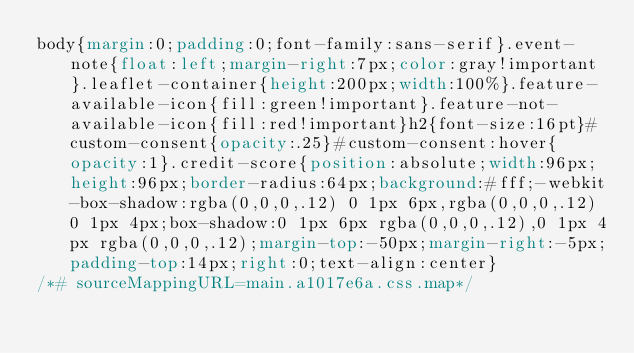Convert code to text. <code><loc_0><loc_0><loc_500><loc_500><_CSS_>body{margin:0;padding:0;font-family:sans-serif}.event-note{float:left;margin-right:7px;color:gray!important}.leaflet-container{height:200px;width:100%}.feature-available-icon{fill:green!important}.feature-not-available-icon{fill:red!important}h2{font-size:16pt}#custom-consent{opacity:.25}#custom-consent:hover{opacity:1}.credit-score{position:absolute;width:96px;height:96px;border-radius:64px;background:#fff;-webkit-box-shadow:rgba(0,0,0,.12) 0 1px 6px,rgba(0,0,0,.12) 0 1px 4px;box-shadow:0 1px 6px rgba(0,0,0,.12),0 1px 4px rgba(0,0,0,.12);margin-top:-50px;margin-right:-5px;padding-top:14px;right:0;text-align:center}
/*# sourceMappingURL=main.a1017e6a.css.map*/</code> 